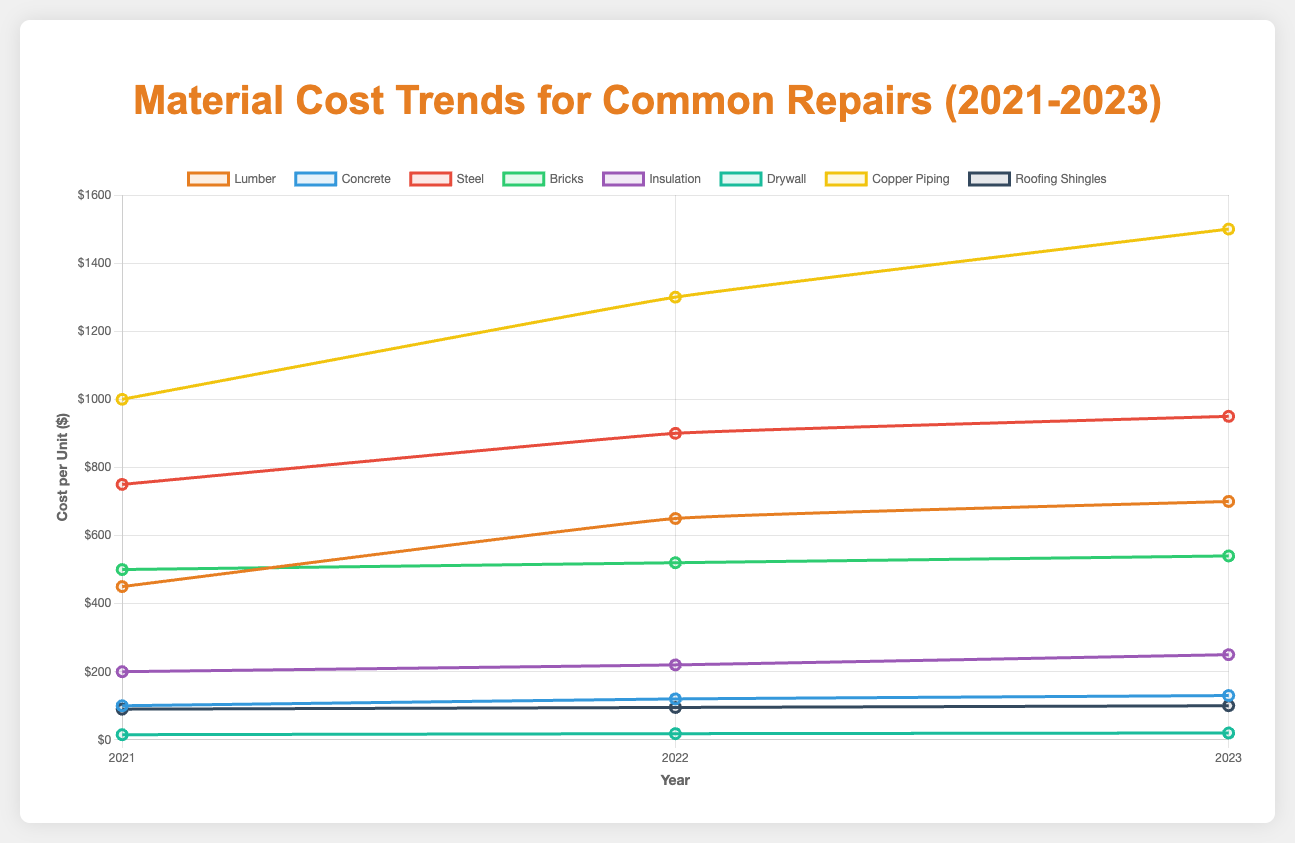What is the trend in the cost of Lumber from 2021 to 2023? To identify the trend, observe the cost of Lumber over the three years on the chart. The cost in 2021 is $450, in 2022 it rises to $650, and in 2023 it further increases to $700. This shows a consistent upward trend.
Answer: Increasing Which material had the highest cost per unit in 2023? Look for the highest point on the chart for the year 2023. Copper Piping has the highest value at $1500.
Answer: Copper Piping How much did the cost of Concrete increase from 2021 to 2023? Find the cost of Concrete in 2021 and 2023, which are $100 and $130 respectively. Calculate the difference: $130 - $100 = $30.
Answer: $30 Which material had the smallest increase in cost from 2021 to 2023? Compare the differences in cost for each material between 2021 and 2023. Drywall increased from $15 to $20, which is a difference of $5. No other material had a smaller increase.
Answer: Drywall Compare the cost of Steel and Lumber in 2022. Which was more expensive and by how much? Find the costs of Steel and Lumber in 2022, which are $900 and $650 respectively. Calculate the difference: $900 - $650 = $250. Steel was more expensive by $250.
Answer: Steel, $250 What is the average cost of Insulation over the three years? Sum up the costs of Insulation across the three years and divide by the number of years: ($200 + $220 + $250) / 3 = $670 / 3 = approximately $223.33.
Answer: $223.33 Between Concrete and Bricks, which material showed a greater increase in cost between 2021 and 2023? Calculate the increase for both materials: Concrete increased from $100 to $130, a $30 rise; Bricks increased from $500 to $540, a $40 rise. Bricks had a greater increase.
Answer: Bricks Which material had the most significant price hike in 2022 compared to 2021? Compare the price increases for each material from 2021 to 2022, identifying Copper Piping increased the most from $1000 to $1300, a $300 increase.
Answer: Copper Piping How did the cost of Roofing Shingles change from 2021 to 2023? Identify the cost of Roofing Shingles for the three years and assess the change. It increased from $90 in 2021, to $95 in 2022, and reached $100 in 2023. The total increase is $100 - $90 = $10.
Answer: Increased by $10 What is the percentage increase in the cost of Steel from 2021 to 2023? Calculate the percentage increase: the cost of Steel in 2021 was $750 and in 2023 it is $950. The increase is $950 - $750 = $200. The percentage increase is ($200 / $750) * 100 ≈ 26.67%.
Answer: 26.67% 